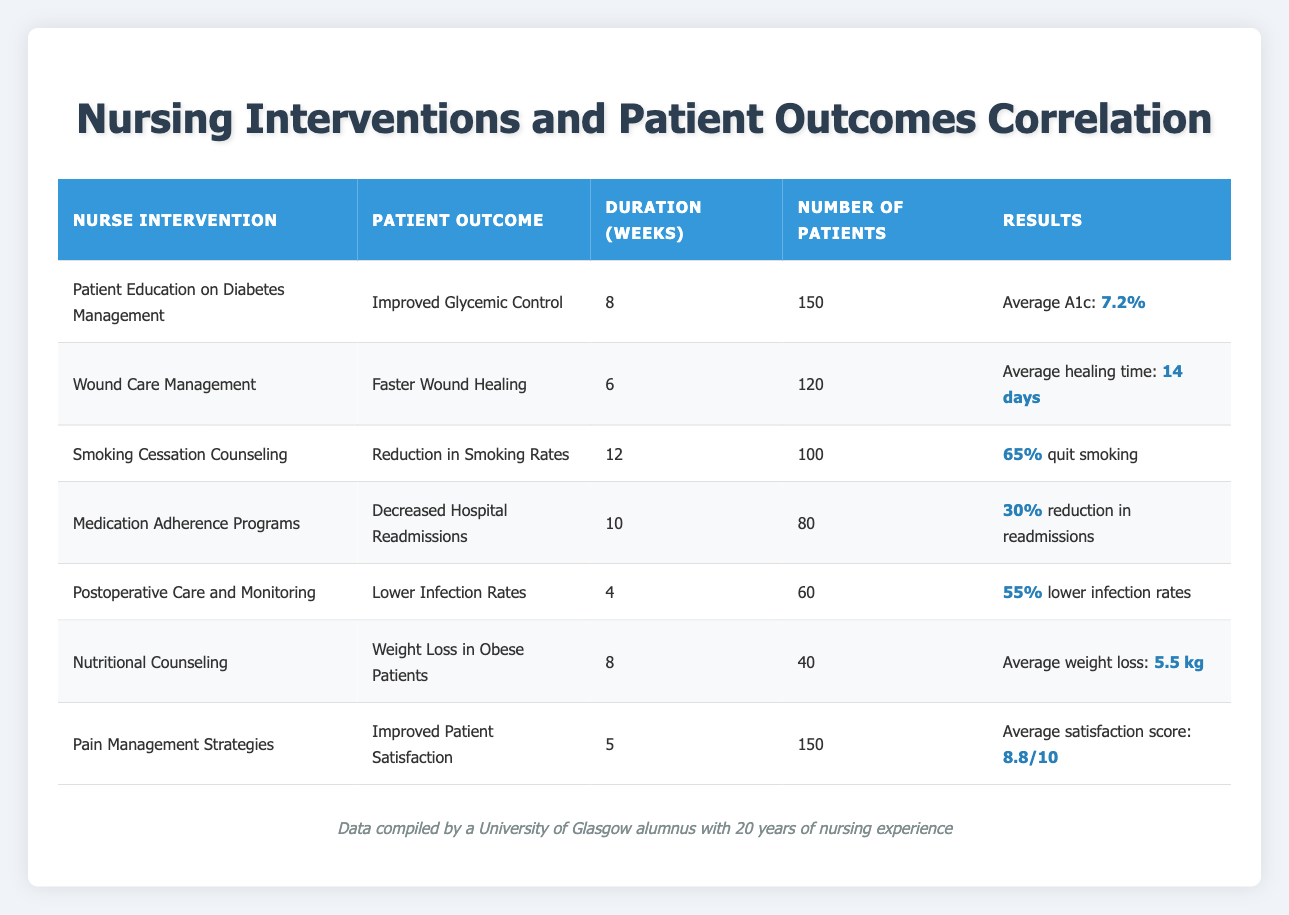What is the average glycated hemoglobin A1c for patients who received diabetes management education? From the table, the only intervention related to diabetes management is "Patient Education on Diabetes Management," which has an average glycated hemoglobin A1c of 7.2%.
Answer: 7.2% How many patients were involved in the Smoking Cessation Counseling intervention? The table indicates that there were 100 patients involved in the "Smoking Cessation Counseling" intervention.
Answer: 100 What was the percentage reduction in hospital readmissions due to Medication Adherence Programs? According to the data for "Medication Adherence Programs," the percentage reduction in hospital readmissions is 30%.
Answer: 30% Which intervention resulted in the highest average patient satisfaction score? The intervention "Pain Management Strategies" resulted in the highest average patient satisfaction score of 8.8 out of 10, which is higher than all other interventions listed.
Answer: Pain Management Strategies Is the average time to heal for wounds lower than 14 days? The table shows that the average healing time for the "Wound Care Management" intervention is 14 days, so it is not lower than that.
Answer: No What is the average weight loss for patients receiving Nutritional Counseling? The "Nutritional Counseling" intervention reports an average weight loss of 5.5 kg for patients, as specified in the table.
Answer: 5.5 kg If we combine the number of patients from Postoperative Care and Medication Adherence Programs, how many patients were involved in total? The total number of patients is calculated by adding 60 (Postoperative Care) and 80 (Medication Adherence Programs), giving a total of 140 patients involved.
Answer: 140 Which intervention had the shortest duration and what was the outcome? The "Postoperative Care and Monitoring" intervention had the shortest duration of 4 weeks, resulting in "Lower Infection Rates."
Answer: Postoperative Care and Monitoring; Lower Infection Rates How many interventions resulted in over a 50% improvement in patient outcomes? Looking at the table, the interventions "Smoking Cessation Counseling" (65% quit smoking) and "Postoperative Care and Monitoring" (55% lower infection rates) both exceeded a 50% improvement in their outcomes, resulting in a total of 2 interventions.
Answer: 2 